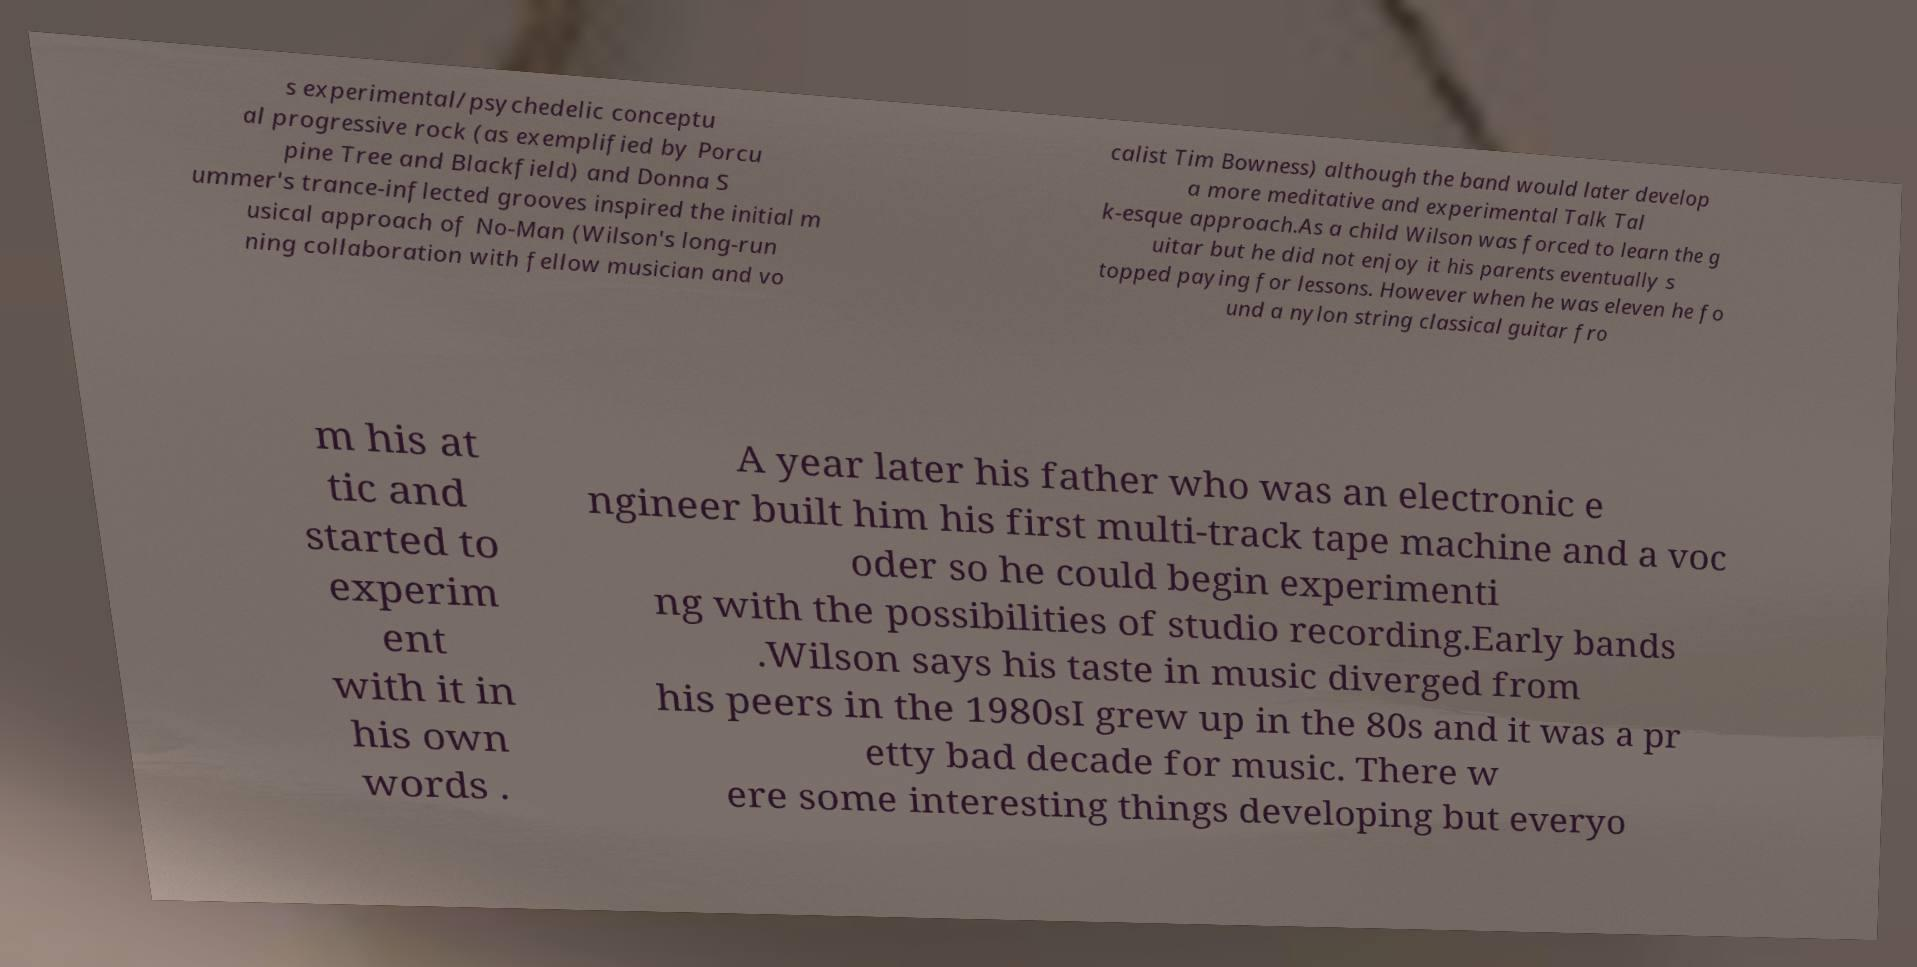Could you extract and type out the text from this image? s experimental/psychedelic conceptu al progressive rock (as exemplified by Porcu pine Tree and Blackfield) and Donna S ummer's trance-inflected grooves inspired the initial m usical approach of No-Man (Wilson's long-run ning collaboration with fellow musician and vo calist Tim Bowness) although the band would later develop a more meditative and experimental Talk Tal k-esque approach.As a child Wilson was forced to learn the g uitar but he did not enjoy it his parents eventually s topped paying for lessons. However when he was eleven he fo und a nylon string classical guitar fro m his at tic and started to experim ent with it in his own words . A year later his father who was an electronic e ngineer built him his first multi-track tape machine and a voc oder so he could begin experimenti ng with the possibilities of studio recording.Early bands .Wilson says his taste in music diverged from his peers in the 1980sI grew up in the 80s and it was a pr etty bad decade for music. There w ere some interesting things developing but everyo 